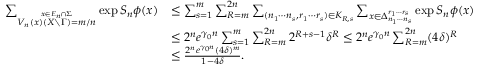Convert formula to latex. <formula><loc_0><loc_0><loc_500><loc_500>\begin{array} { r l } { \sum _ { \stackrel { x \in E _ { n } \cap \Sigma } { V _ { n } ( x ) ( X \ \Gamma ) = m / n } } \exp S _ { n } \phi ( x ) } & { \leq \sum _ { s = 1 } ^ { m } \sum _ { R = m } ^ { 2 n } \sum _ { ( n _ { 1 } \cdots n _ { s } , r _ { 1 } \cdots r _ { s } ) \in K _ { R , s } } \sum _ { x \in \Delta _ { n _ { 1 } \cdots n _ { s } } ^ { r _ { 1 } \cdots r _ { s } } } \exp S _ { n } \phi ( x ) } \\ & { \leq 2 ^ { n } e ^ { \gamma _ { 0 } n } \sum _ { s = 1 } ^ { m } \sum _ { R = m } ^ { 2 n } 2 ^ { R + s - 1 } \delta ^ { R } \leq 2 ^ { n } e ^ { \gamma _ { 0 } n } \sum _ { R = m } ^ { 2 n } ( 4 \delta ) ^ { R } } \\ & { \leq \frac { 2 ^ { n } e ^ { \gamma _ { 0 } n } ( 4 \delta ) ^ { m } } { 1 - 4 \delta } . } \end{array}</formula> 